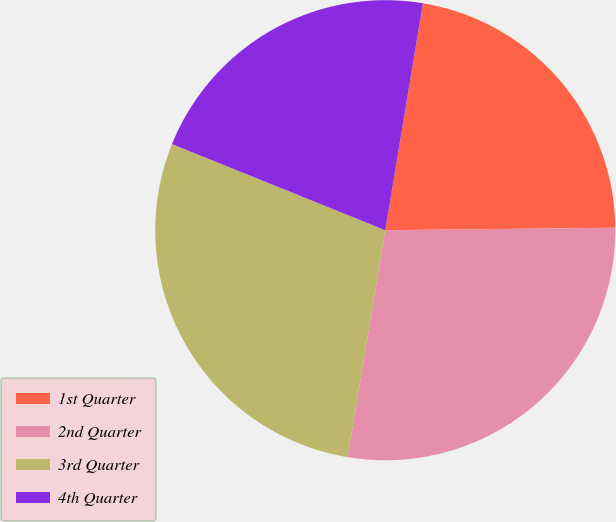Convert chart. <chart><loc_0><loc_0><loc_500><loc_500><pie_chart><fcel>1st Quarter<fcel>2nd Quarter<fcel>3rd Quarter<fcel>4th Quarter<nl><fcel>22.21%<fcel>27.78%<fcel>28.49%<fcel>21.51%<nl></chart> 